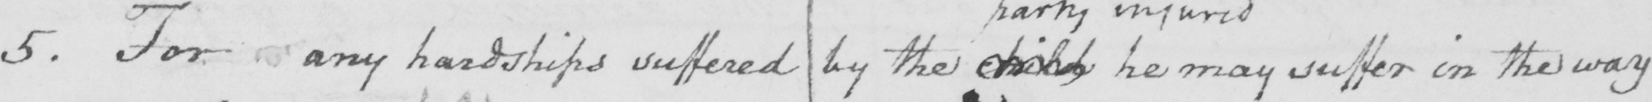What text is written in this handwritten line? 5 . For any hardships suffered by the child he may suffer in the way 